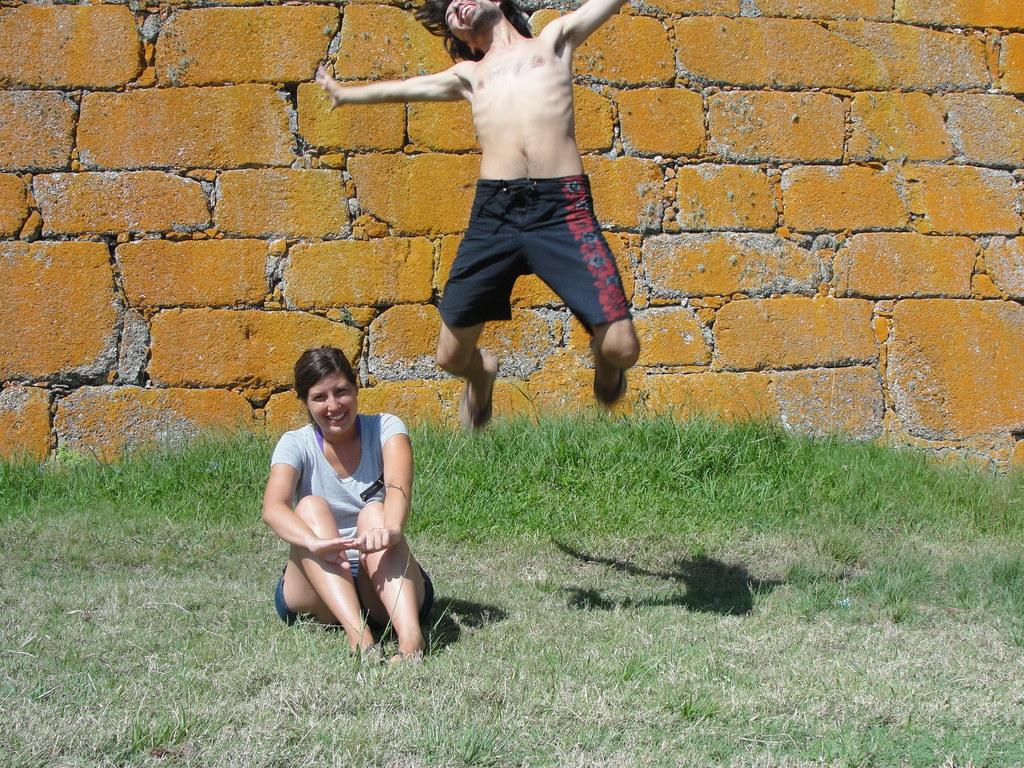How many people are in the image? There are two people in the image. What is the facial expression of the people in the image? Both people are smiling. What is the woman doing in the image? The woman is sitting on the grass. What is the man doing in the image? The man is in the air. What can be seen in the background of the image? There is a wall in the background of the image. What type of spark can be seen coming from the woman's hand in the image? There is no spark visible in the image; both people are simply smiling. 